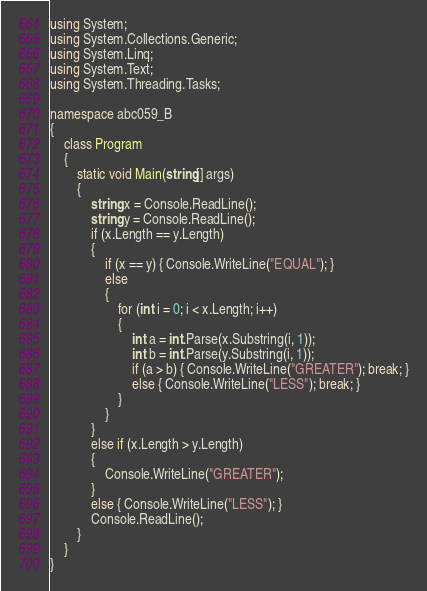<code> <loc_0><loc_0><loc_500><loc_500><_C#_>using System;
using System.Collections.Generic;
using System.Linq;
using System.Text;
using System.Threading.Tasks;

namespace abc059_B
{
    class Program
    {
        static void Main(string[] args)
        {
            string x = Console.ReadLine();
            string y = Console.ReadLine();
            if (x.Length == y.Length)
            {
                if (x == y) { Console.WriteLine("EQUAL"); }
                else
                {
                    for (int i = 0; i < x.Length; i++)
                    {
                        int a = int.Parse(x.Substring(i, 1));
                        int b = int.Parse(y.Substring(i, 1));
                        if (a > b) { Console.WriteLine("GREATER"); break; }
                        else { Console.WriteLine("LESS"); break; }
                    }
                }
            }
            else if (x.Length > y.Length)
            {
                Console.WriteLine("GREATER");
            }
            else { Console.WriteLine("LESS"); }
            Console.ReadLine();
        }
    }
}
</code> 